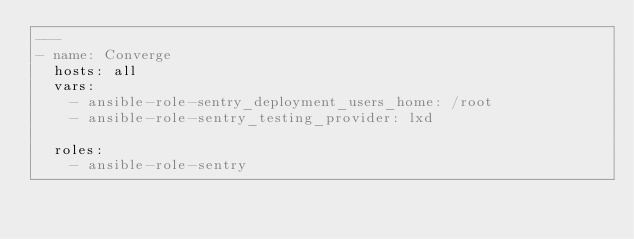Convert code to text. <code><loc_0><loc_0><loc_500><loc_500><_YAML_>---
- name: Converge
  hosts: all
  vars:
    - ansible-role-sentry_deployment_users_home: /root
    - ansible-role-sentry_testing_provider: lxd

  roles:
    - ansible-role-sentry</code> 